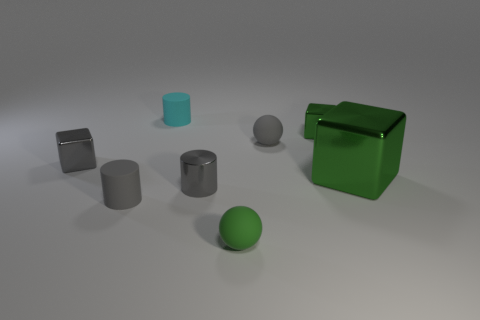The other small sphere that is made of the same material as the gray sphere is what color?
Keep it short and to the point. Green. What is the shape of the cyan matte thing?
Provide a succinct answer. Cylinder. How many small shiny blocks have the same color as the small metal cylinder?
Your answer should be compact. 1. The green metal thing that is the same size as the green sphere is what shape?
Offer a terse response. Cube. Are there any cyan rubber cylinders of the same size as the gray block?
Give a very brief answer. Yes. There is a green ball that is the same size as the cyan matte thing; what material is it?
Offer a very short reply. Rubber. There is a matte thing in front of the rubber cylinder in front of the tiny cyan matte cylinder; what size is it?
Your response must be concise. Small. There is a gray metallic object left of the metal cylinder; is it the same size as the metallic cylinder?
Make the answer very short. Yes. Are there more tiny cyan cylinders right of the small gray sphere than objects that are on the left side of the tiny shiny cylinder?
Keep it short and to the point. No. The rubber object that is both to the left of the green sphere and in front of the small green cube has what shape?
Provide a short and direct response. Cylinder. 